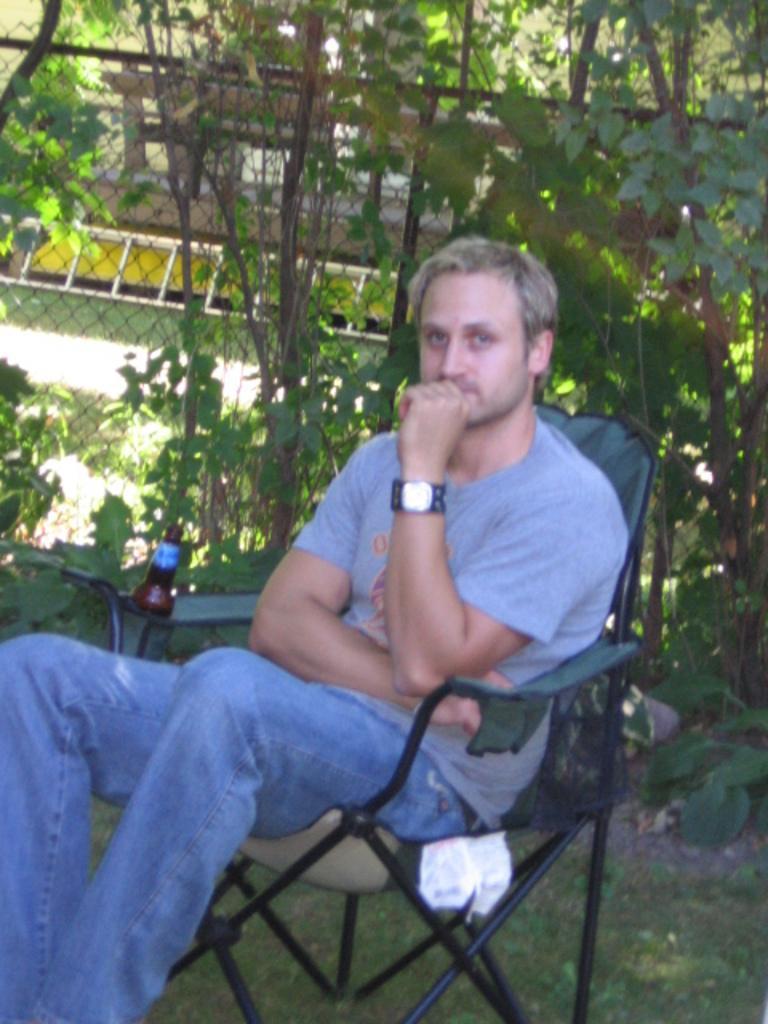In one or two sentences, can you explain what this image depicts? In the image there is a man sitting on a chair in a garden, beside him there is a bottle and behind the man there is a mesh and there are also few plants. 